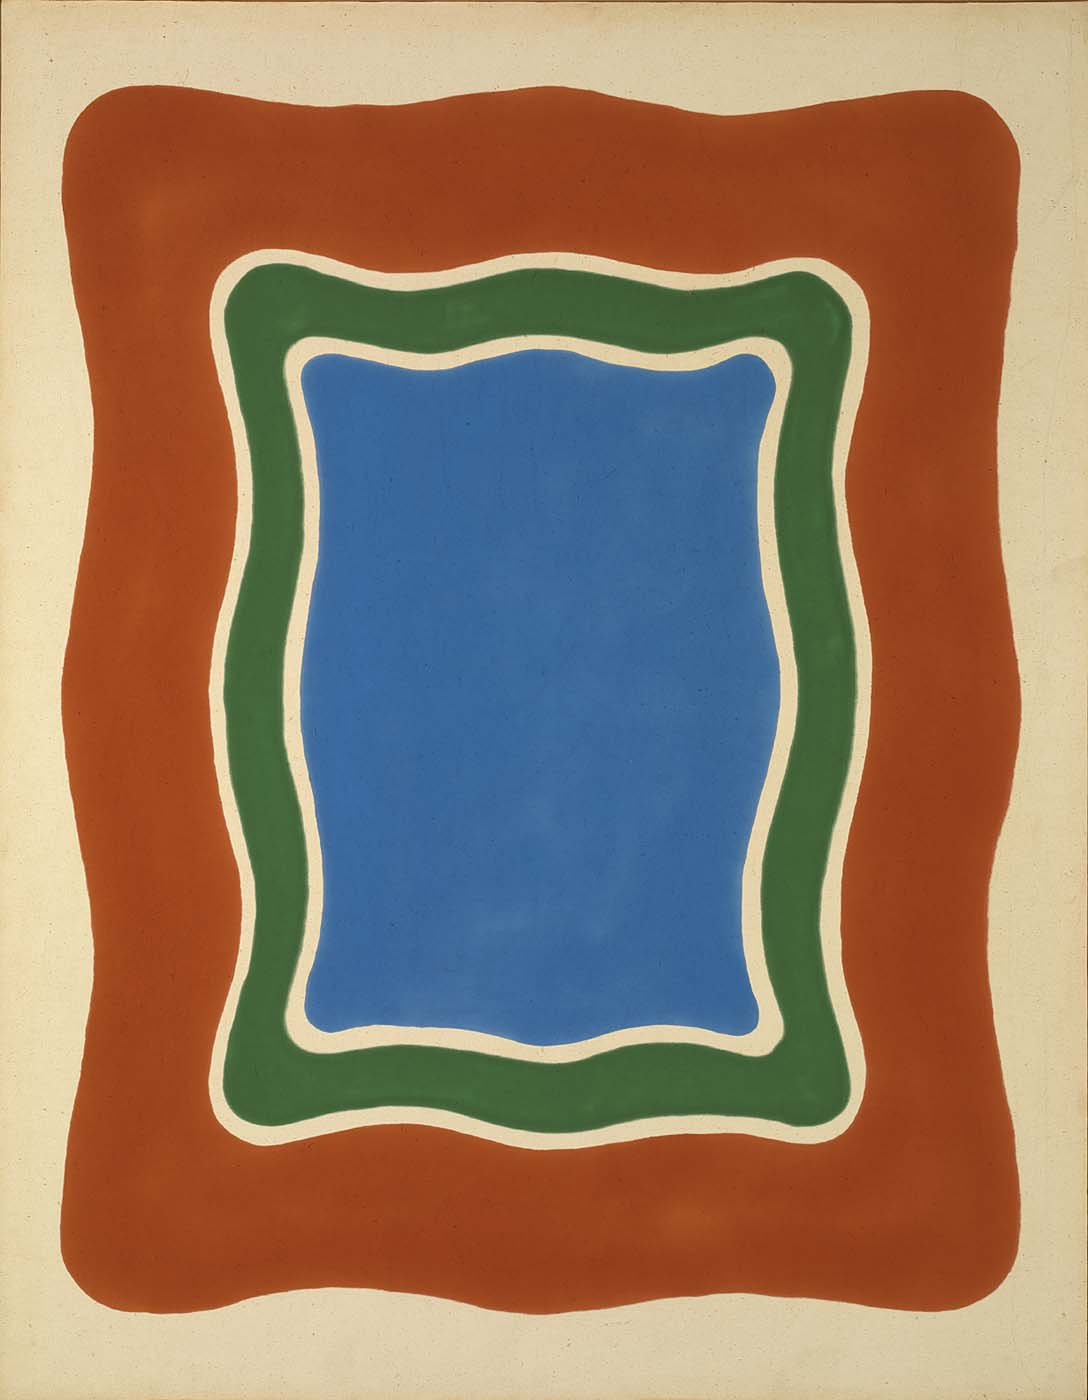Can you discuss the significance of the organic, curved lines used in the artwork? The organic, curvy lines used in the artwork soften the geometric rigidity that shapes typically convey, introducing a more natural, fluid element to the composition. This choice can symbolize the merging of human-made structures with natural forms, implying a harmony between man and nature. Additionally, the curves can be seen as a stylistic nod to the unpredictability and the non-linear aspects of both art and life, suggesting movement and change. 